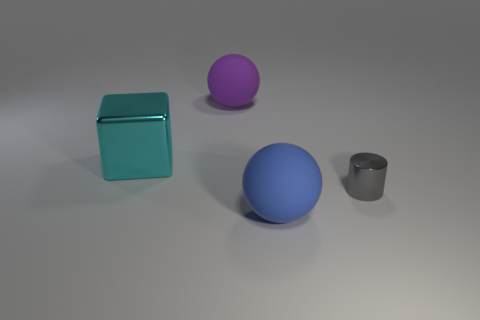Add 2 big blue rubber things. How many objects exist? 6 Subtract all cubes. How many objects are left? 3 Subtract all blue cylinders. Subtract all gray balls. How many cylinders are left? 1 Subtract all brown rubber objects. Subtract all matte spheres. How many objects are left? 2 Add 2 cyan metal blocks. How many cyan metal blocks are left? 3 Add 1 rubber objects. How many rubber objects exist? 3 Subtract 0 red blocks. How many objects are left? 4 